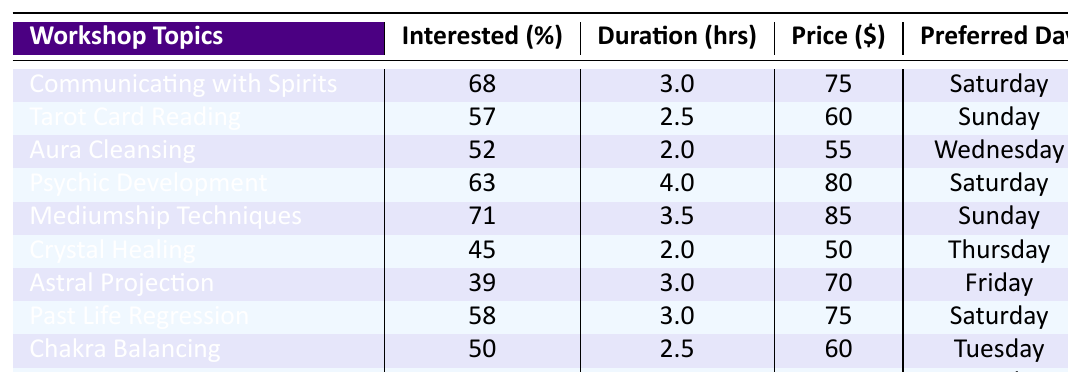What is the workshop topic with the highest interest percentage? By reviewing the table, the "Communicating with Spirits" workshop has the highest interest percentage at 68%.
Answer: Communicating with Spirits What percentage of participants are interested in Crystal Healing? The table shows that 45% of participants are interested in Crystal Healing.
Answer: 45% What is the average duration of the workshops listed? To find the average, add the duration values: (3 + 2.5 + 2 + 4 + 3.5 + 2 + 3 + 3 + 2.5 + 2) = 24. The number of workshops is 10, so the average is 24 / 10 = 2.4 hours.
Answer: 2.4 hours Is there a workshop on Friday? Yes, there is a workshop on Friday, which is "Astral Projection."
Answer: Yes Which workshop has the suggested price of $80? According to the table, the workshop with a suggested price of $80 is "Psychic Development."
Answer: Psychic Development What is the lowest percentage of interest among the workshop topics? The lowest percentage of interest is for "Astral Projection," which has 39% interested participants.
Answer: 39% Which day of the week has the highest number of suggested workshops? The day with the highest number of suggested workshops is Saturday, with three workshops: "Communicating with Spirits," "Psychic Development," and "Past Life Regression."
Answer: Saturday What is the total suggested price of all workshops combined? Adding the suggested prices: (75 + 60 + 55 + 80 + 85 + 50 + 70 + 75 + 60 + 55) = 665 dollars.
Answer: 665 dollars Is the average percentage of interest greater than 50%? The average interest percentage can be calculated as (68 + 57 + 52 + 63 + 71 + 45 + 39 + 58 + 50 + 42) =  58.5%, which is indeed greater than 50%.
Answer: Yes What is the difference in percentage of interest between the most and least popular workshops? The most popular workshop, "Communicating with Spirits," has 68% interest, and the least popular, "Astral Projection," has 39%. The difference is 68 - 39 = 29%.
Answer: 29% 